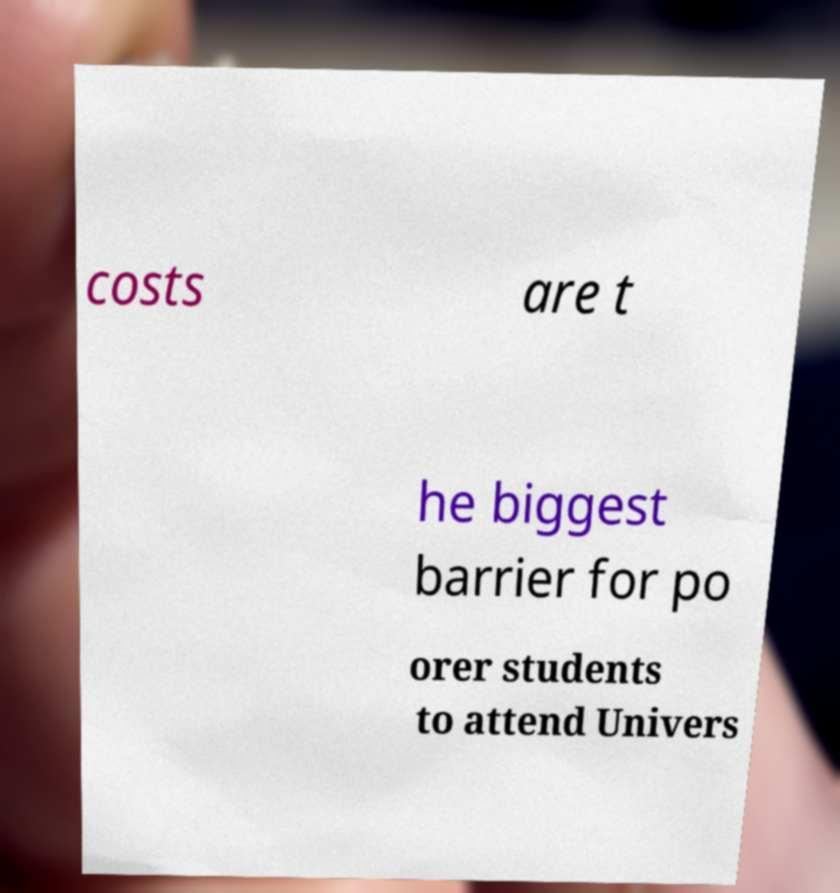Please read and relay the text visible in this image. What does it say? costs are t he biggest barrier for po orer students to attend Univers 